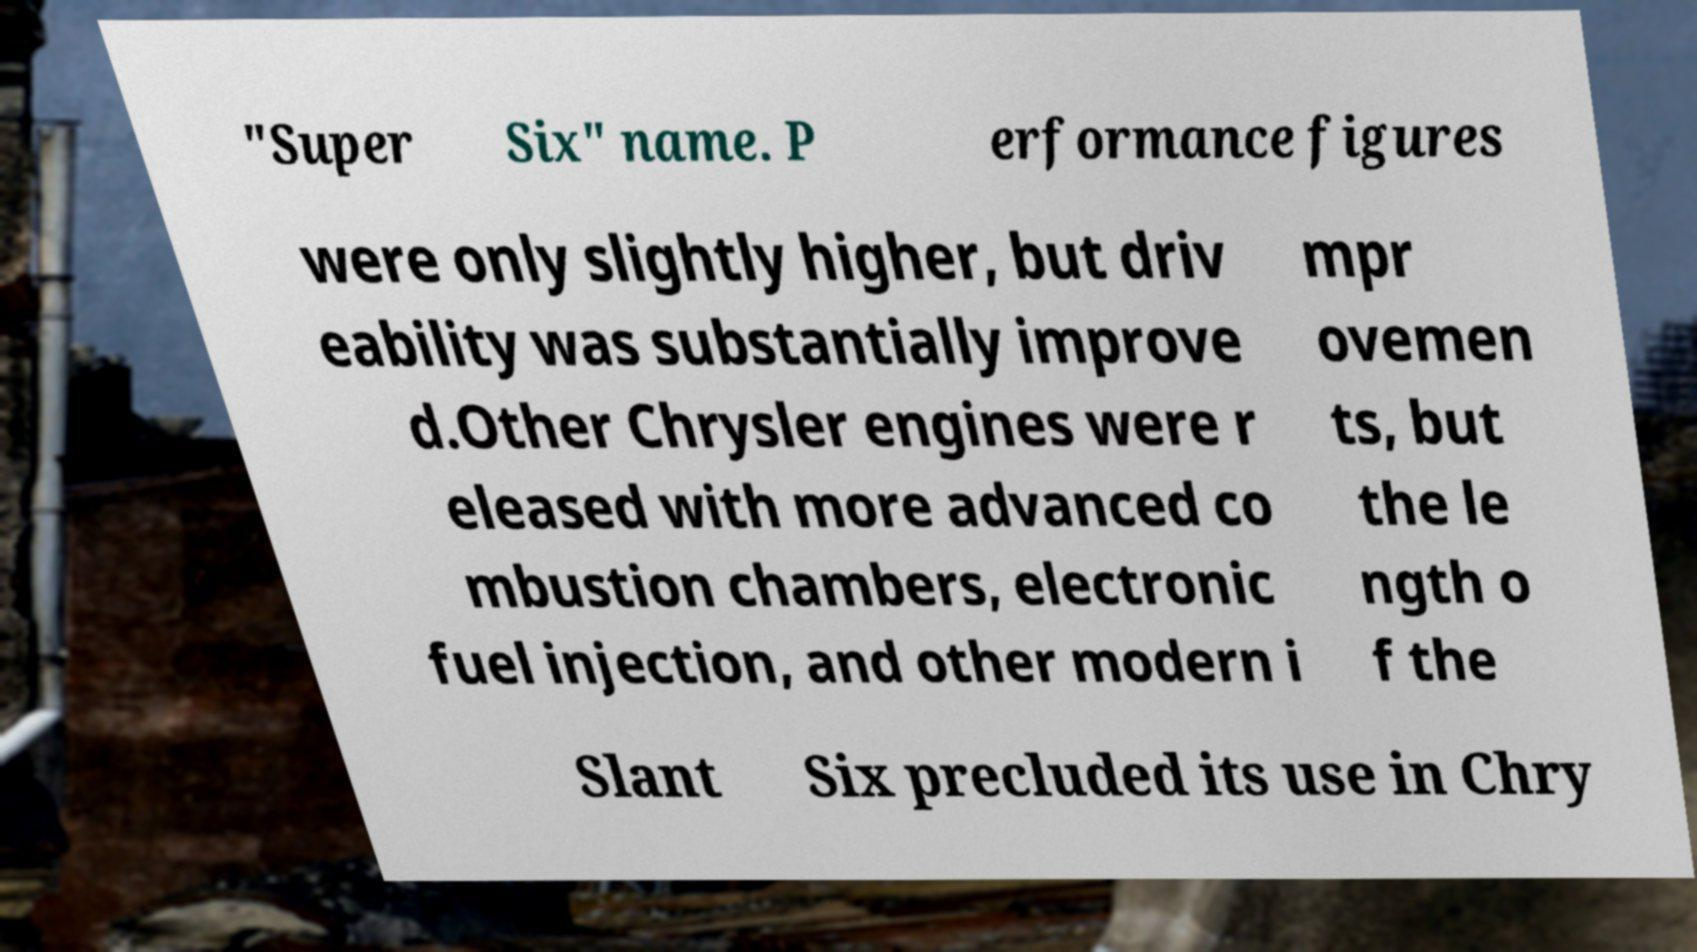Please identify and transcribe the text found in this image. "Super Six" name. P erformance figures were only slightly higher, but driv eability was substantially improve d.Other Chrysler engines were r eleased with more advanced co mbustion chambers, electronic fuel injection, and other modern i mpr ovemen ts, but the le ngth o f the Slant Six precluded its use in Chry 